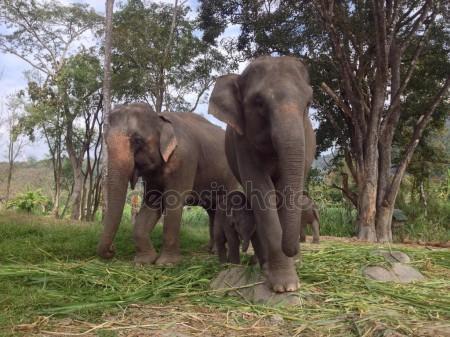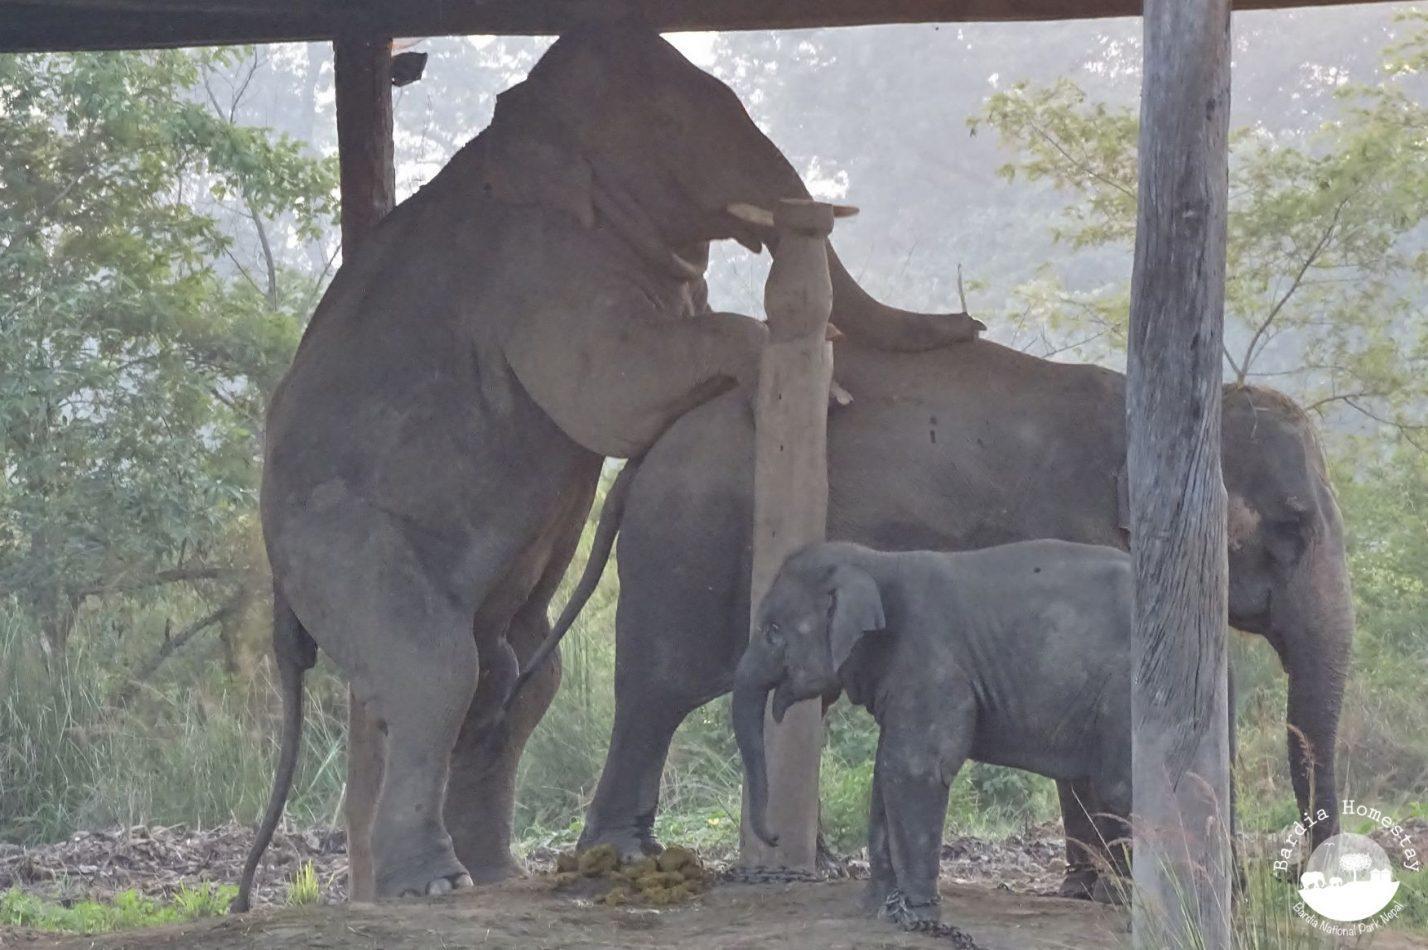The first image is the image on the left, the second image is the image on the right. Examine the images to the left and right. Is the description "An image shows multiple people in a scene containing several elephants." accurate? Answer yes or no. No. The first image is the image on the left, the second image is the image on the right. For the images shown, is this caption "There are less than three elephants in at least one of the images." true? Answer yes or no. No. 